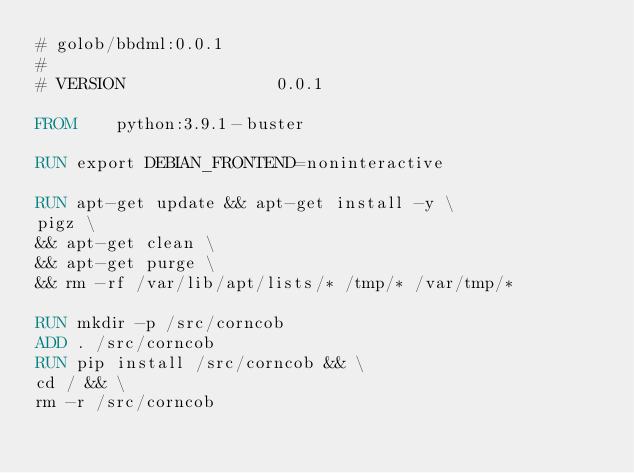Convert code to text. <code><loc_0><loc_0><loc_500><loc_500><_Dockerfile_># golob/bbdml:0.0.1
#
# VERSION               0.0.1

FROM    python:3.9.1-buster

RUN export DEBIAN_FRONTEND=noninteractive

RUN apt-get update && apt-get install -y \
pigz \
&& apt-get clean \
&& apt-get purge \
&& rm -rf /var/lib/apt/lists/* /tmp/* /var/tmp/*

RUN mkdir -p /src/corncob
ADD . /src/corncob
RUN pip install /src/corncob && \
cd / && \
rm -r /src/corncob</code> 